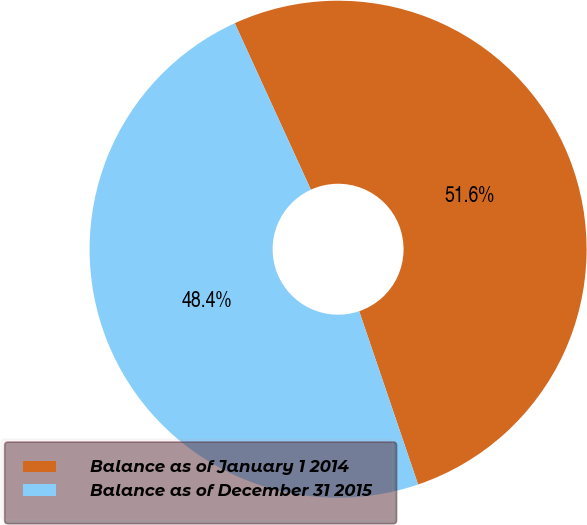Convert chart to OTSL. <chart><loc_0><loc_0><loc_500><loc_500><pie_chart><fcel>Balance as of January 1 2014<fcel>Balance as of December 31 2015<nl><fcel>51.61%<fcel>48.39%<nl></chart> 